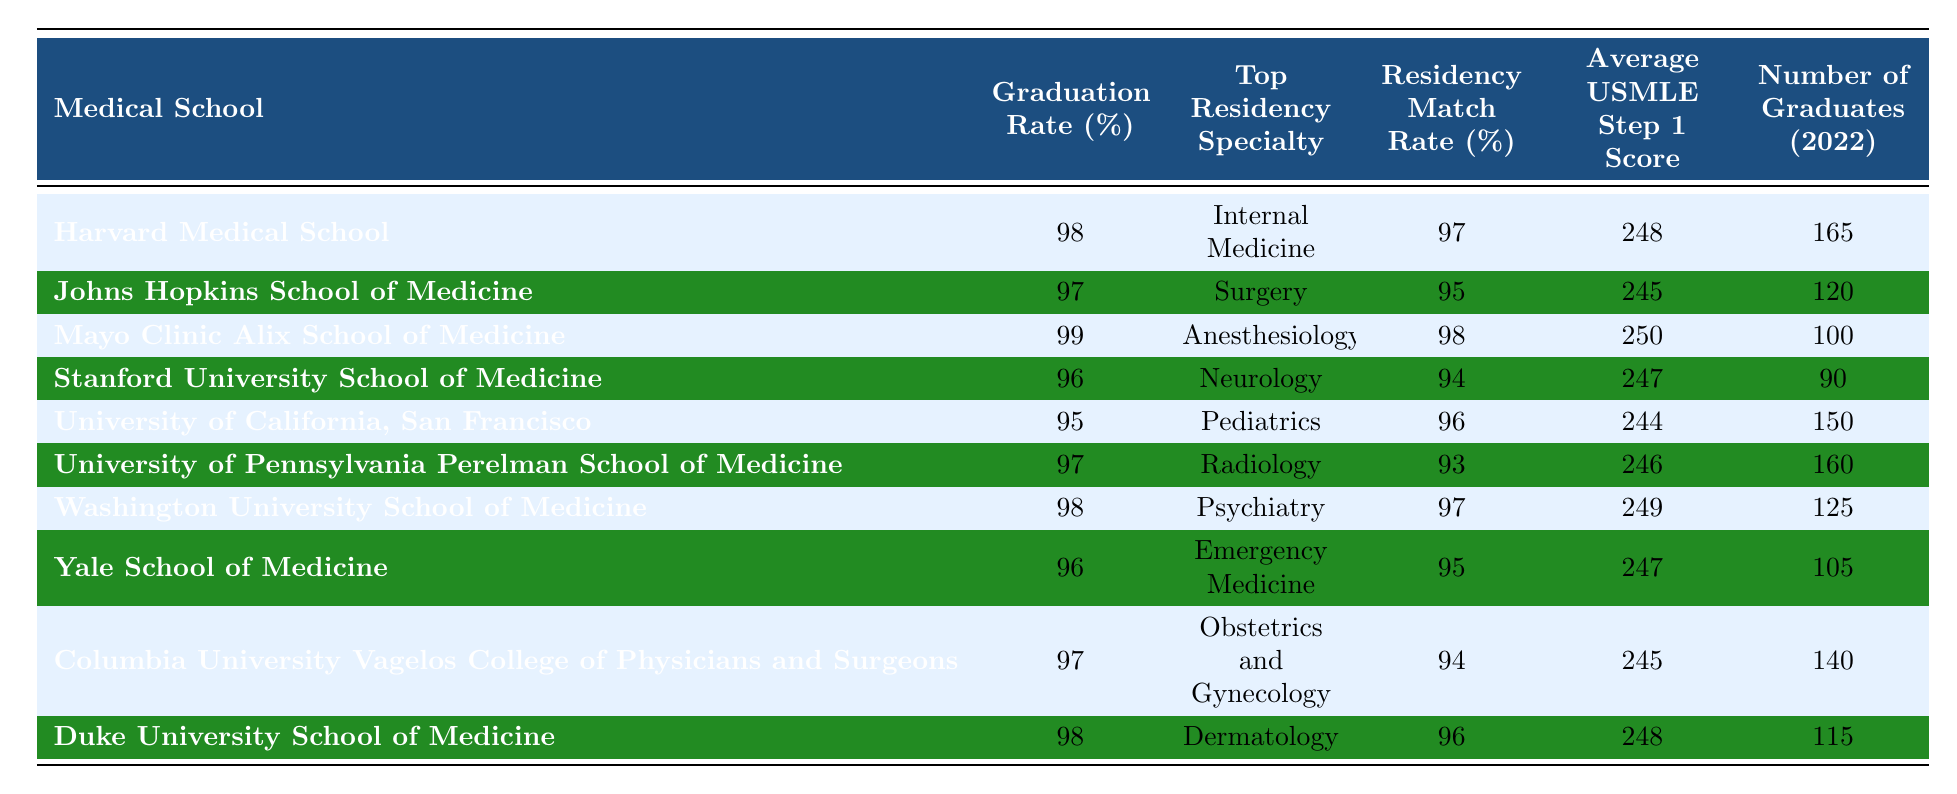What is the graduation rate of Harvard Medical School? The table lists Harvard Medical School’s graduation rate under the corresponding column. It shows a graduation rate of 98%.
Answer: 98% Which medical school has the highest average USMLE Step 1 score? By comparing the average USMLE Step 1 scores in the table, Mayo Clinic Alix School of Medicine has the highest score at 250.
Answer: Mayo Clinic Alix School of Medicine What is the residency match rate for the University of California, San Francisco? The table indicates the residency match rate for the University of California, San Francisco in the appropriate column, which is 96%.
Answer: 96% Do more than half of the graduates from Stanford University School of Medicine match into a residency? Stanford University School of Medicine has a residency match rate of 94%, which exceeds half (50%); therefore, the statement is true.
Answer: Yes What is the average graduation rate of the listed medical schools? To find the average graduation rate, we sum the graduation rates (98 + 97 + 99 + 96 + 95 + 97 + 98 + 96 + 97 + 98) = 979, and divide by 10, giving us 97.9%.
Answer: 97.9% Which residency specialty has the lowest match rate among the schools? By reviewing the residency match rates, the lowest match rate noted in the table is for University of Pennsylvania Perelman School of Medicine with 93%.
Answer: Radiology How many graduates from Johns Hopkins School of Medicine match into a residency? The number of graduates from Johns Hopkins School of Medicine, as indicated in the table, is 120. The residency match rate is 95%. So, the number of graduates that matched is 95% of 120, which is 114.
Answer: 114 Which medical school has the highest residency match rate, and what is that rate? The highest residency match rate in the table is for both Harvard Medical School and Washington University School of Medicine, both showing a match rate of 97%.
Answer: Harvard Medical School and Washington University School of Medicine, 97% If we consider all schools, what is the total number of graduates? We can find the total number of graduates by summing the specified column: (165 + 120 + 100 + 90 + 150 + 160 + 125 + 105 + 140 + 115) = 1,050.
Answer: 1,050 Which two medical schools have the same top residency specialty of Internal Medicine? Checking through the table, Harvard Medical School is matched with Internal Medicine, while no other school matches this specialty. Therefore, there is only one school with this specialty.
Answer: No other school matches 